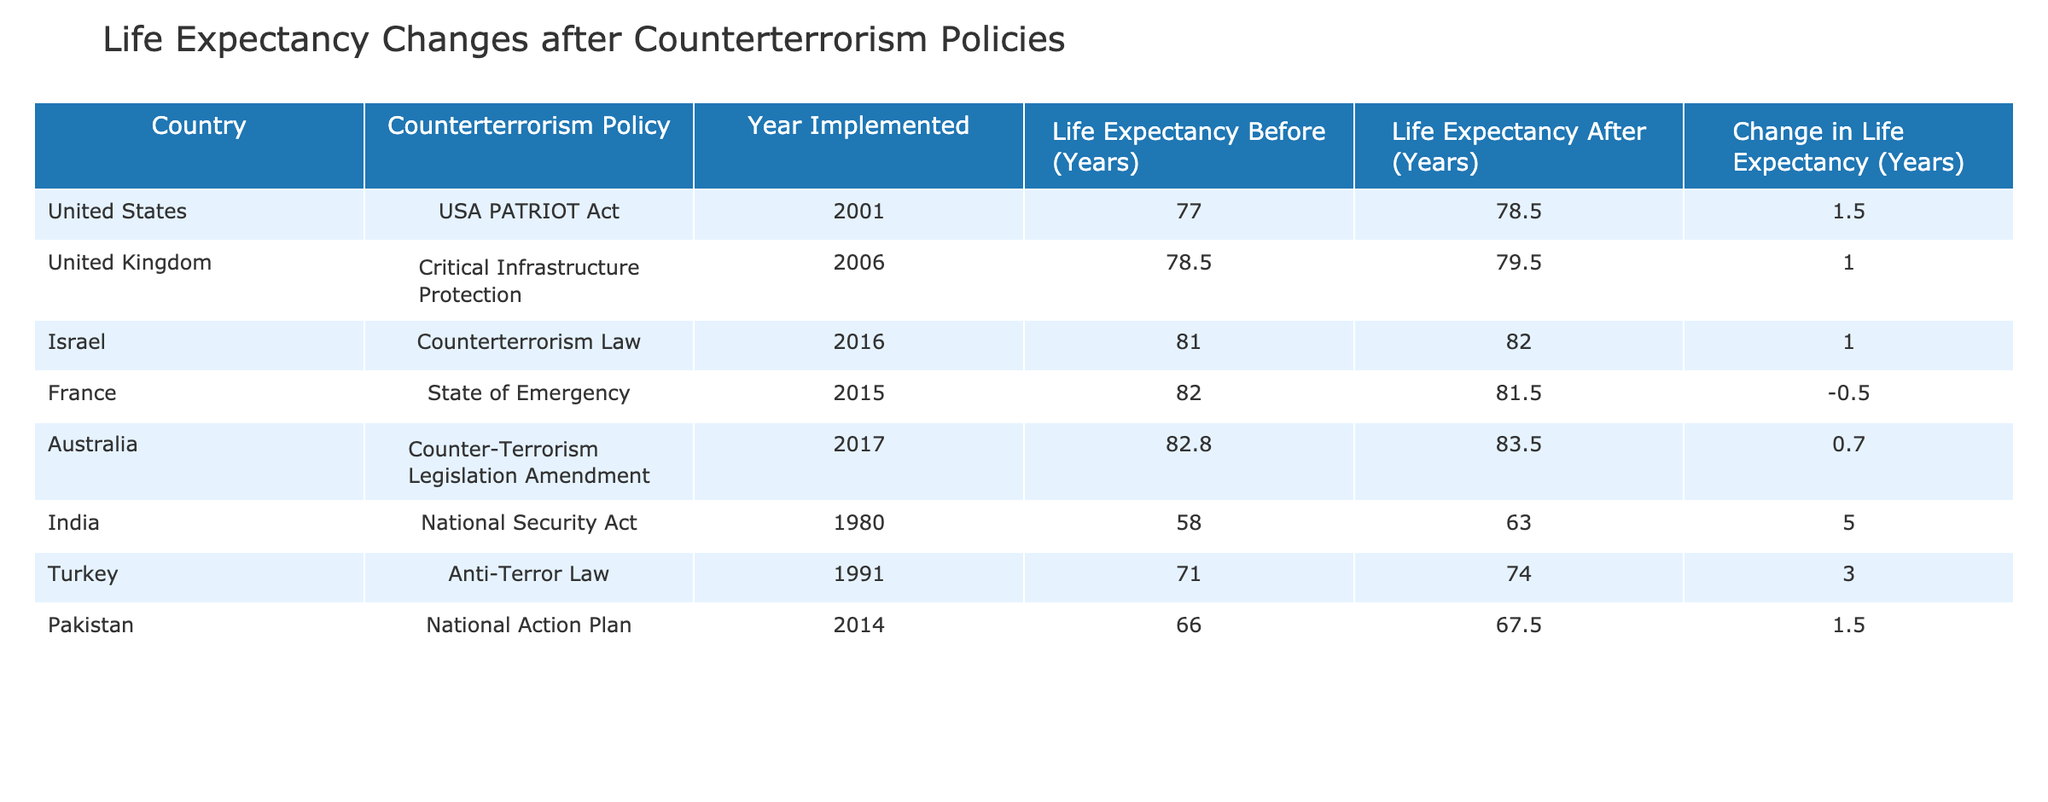What was the life expectancy in India before the National Security Act? The table indicates that the life expectancy in India before the National Security Act was listed as 58.0 years.
Answer: 58.0 years How much did life expectancy change in the United States after the implementation of the USA PATRIOT Act? According to the table, the change in life expectancy in the United States after the implementation of the USA PATRIOT Act was an increase of 1.5 years.
Answer: 1.5 years Did the life expectancy in France increase or decrease after the State of Emergency in 2015? The table shows that the life expectancy in France decreased by 0.5 years after the State of Emergency in 2015, indicating a negative change.
Answer: Decrease Which country had the highest change in life expectancy after counterterrorism measures were implemented? By examining the changes in life expectancy for each country, India had the highest change at 5.0 years following the National Security Act, which is greater than other countries listed.
Answer: India What is the average life expectancy change across all countries listed? To calculate the average life expectancy change, we sum all the changes: (1.5 + 1.0 + 1.0 - 0.5 + 0.7 + 5.0 + 3.0 + 1.5) = 13.2 years. There are 8 data points, so the average is 13.2 / 8 = 1.65 years.
Answer: 1.65 years Was the change in life expectancy after the Anti-Terror Law in Turkey greater than the change in life expectancy after the Critical Infrastructure Protection in the United Kingdom? The change for Turkey was 3.0 years and for the UK it was 1.0 years; since 3.0 is greater than 1.0, the statement is true.
Answer: Yes How many countries implemented counterterrorism policies that led to an increase in life expectancy? By reviewing the table, we find that the countries with an increase in life expectancy after counterterrorism policies are the United States, United Kingdom, Israel, Australia, India, and Turkey, totaling 6 countries.
Answer: 6 countries What was the life expectancy after the Counterterrorism Law in Israel? The life expectancy after the Counterterrorism Law in Israel, as indicated in the table, was 82.0 years.
Answer: 82.0 years Which two countries had the same increase in life expectancy of 1.0 years? The United Kingdom and Israel both had an increase in life expectancy of 1.0 years after their respective counterterrorism policies were implemented.
Answer: United Kingdom and Israel 